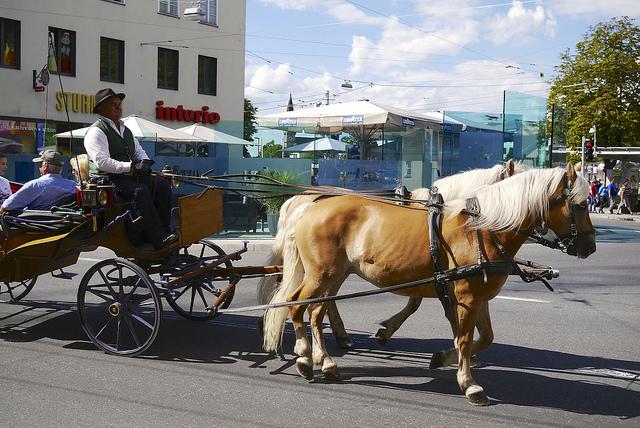Does the man have control of the horses?
Keep it brief. Yes. How many animals are visible?
Short answer required. 2. What color are the horses?
Answer briefly. Brown. 